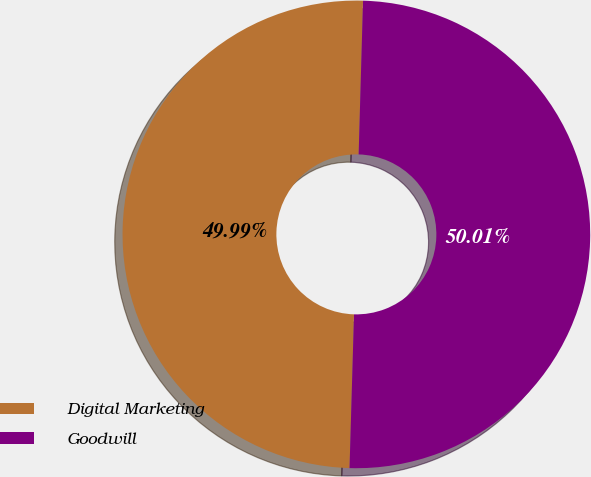Convert chart. <chart><loc_0><loc_0><loc_500><loc_500><pie_chart><fcel>Digital Marketing<fcel>Goodwill<nl><fcel>49.99%<fcel>50.01%<nl></chart> 